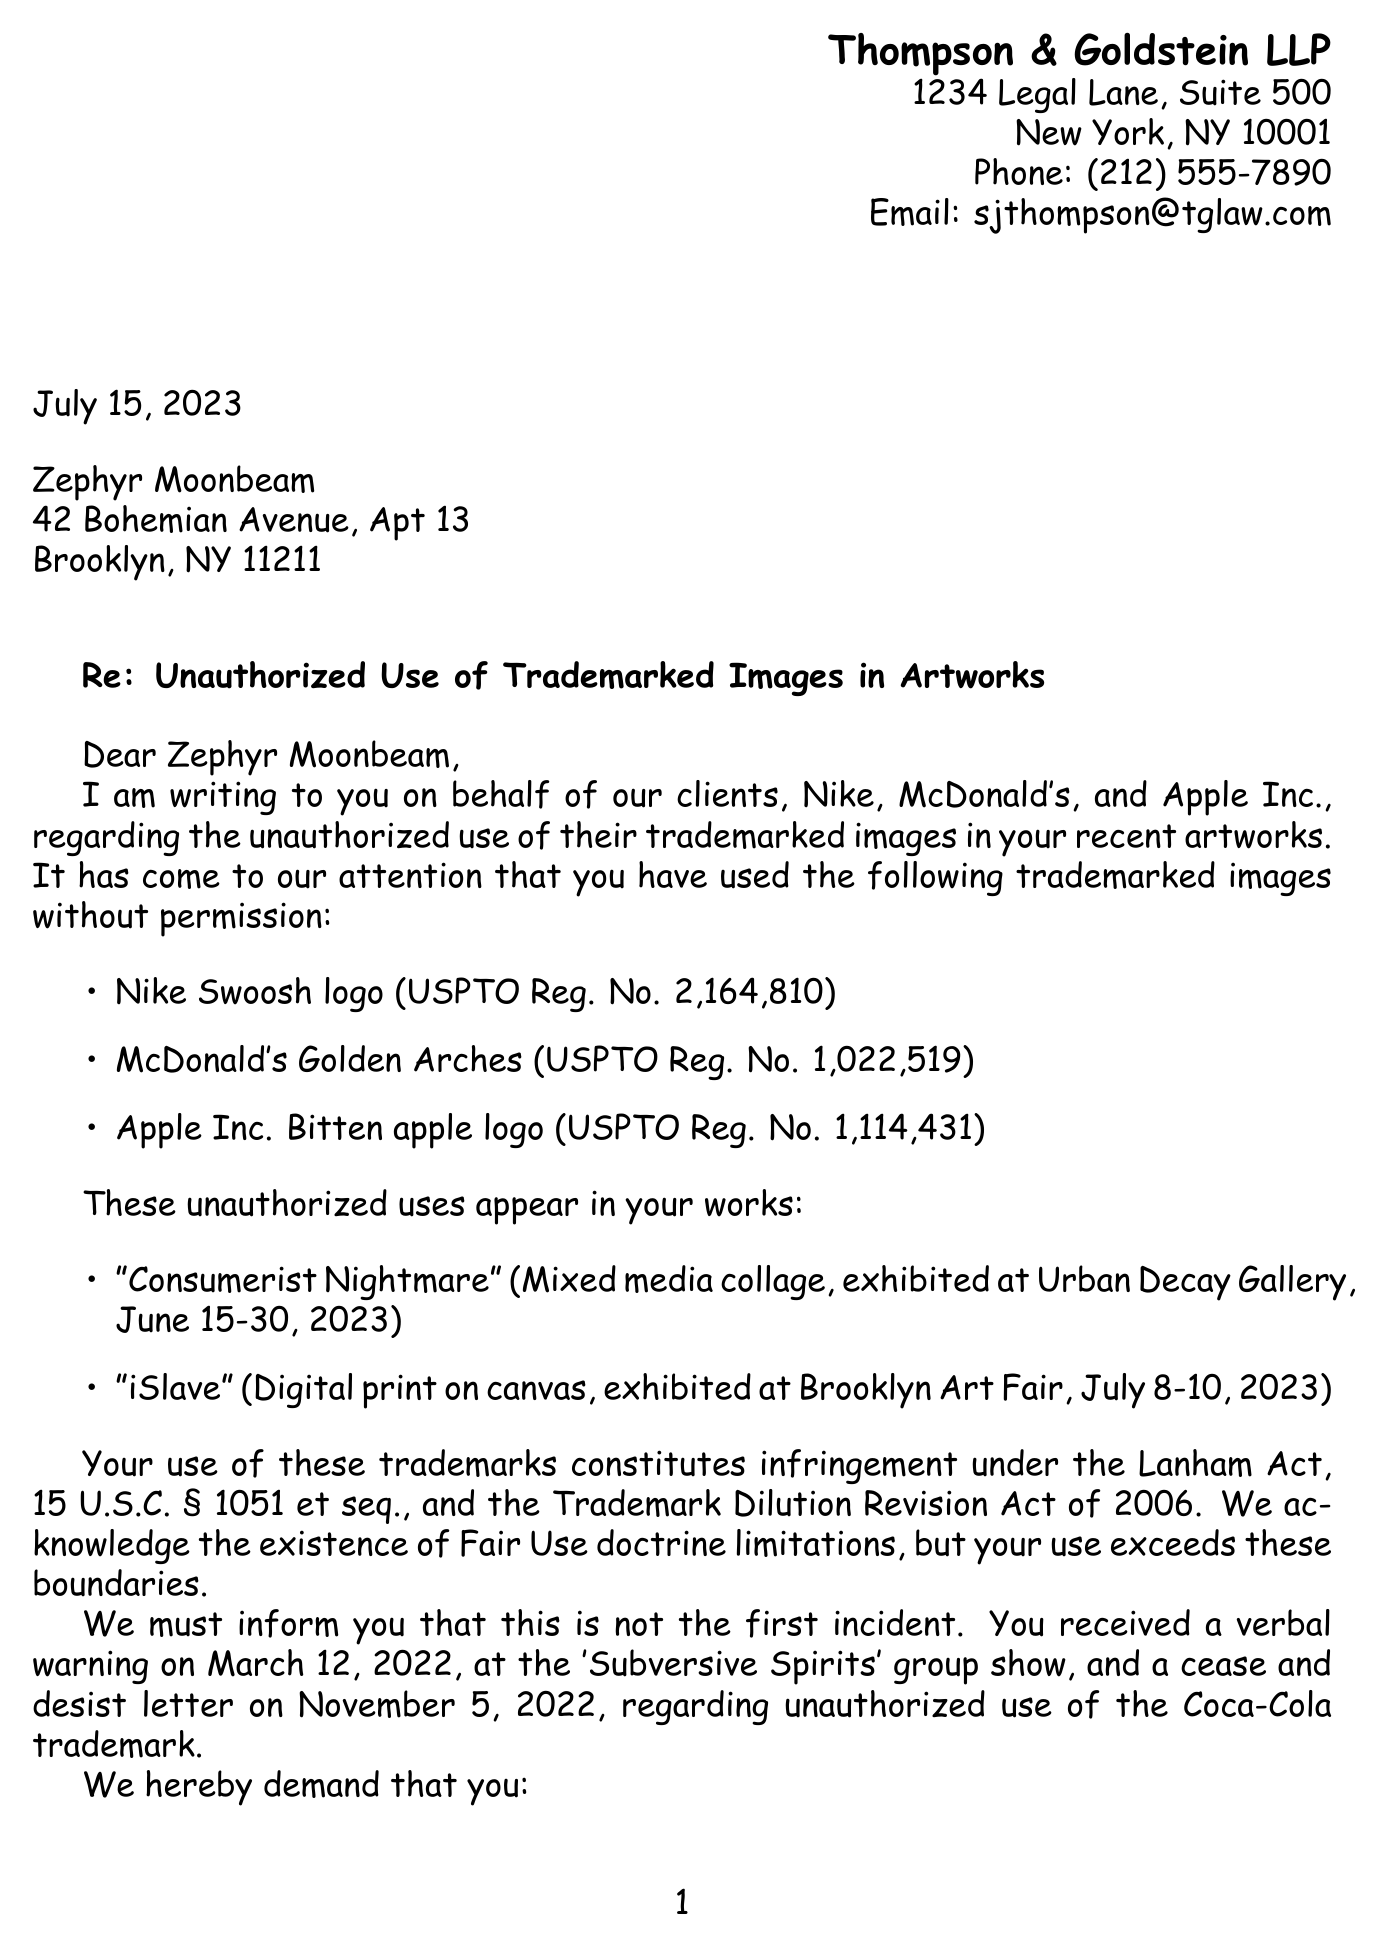What is the name of the law firm? The law firm representing the sender is mentioned at the beginning of the document.
Answer: Thompson & Goldstein LLP Who is the recipient of the letter? The recipient's name is stated in the address section of the letter.
Answer: Zephyr Moonbeam What is the date of the letter? The date is specified in the opening lines of the document.
Answer: July 15, 2023 What is one of the trademarked images mentioned? The document lists trademarked images used in the artworks.
Answer: Nike Swoosh logo What is the title of one infringing artwork? The title of the artworks that are cited for infringement are listed in a specific section.
Answer: Consumerist Nightmare What legal act is mentioned in relation to the infringement? The legal basis for the claims against the recipient is stated in the document.
Answer: Lanham Act What is one of the demands made to the recipient? The demands are outlined in a numbered list in the document.
Answer: Immediate cessation of use of trademarked images What are the potential consequences of non-compliance? The consequences are listed under a specific section regarding legal actions.
Answer: Statutory damages up to $150,000 per infringed work What type of resolution is suggested in the letter? Potential resolutions are mentioned towards the end of the document.
Answer: Licensing agreement for limited use of trademarks 